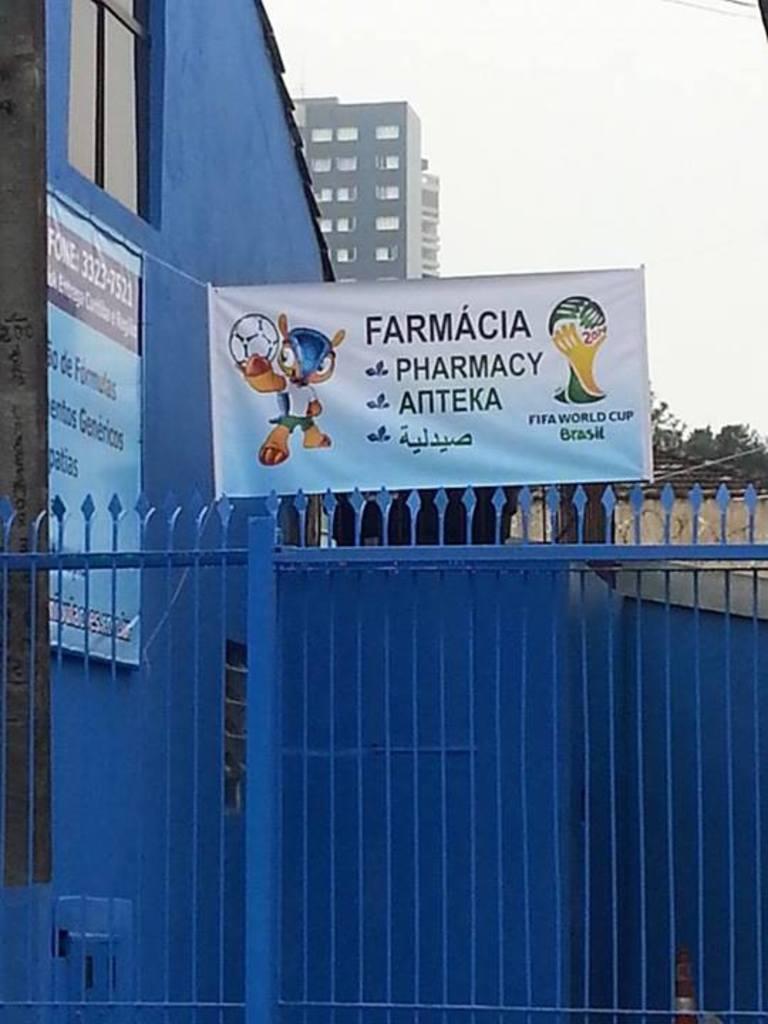What is the first letter of the top worf on the banner?
Provide a succinct answer. F. 